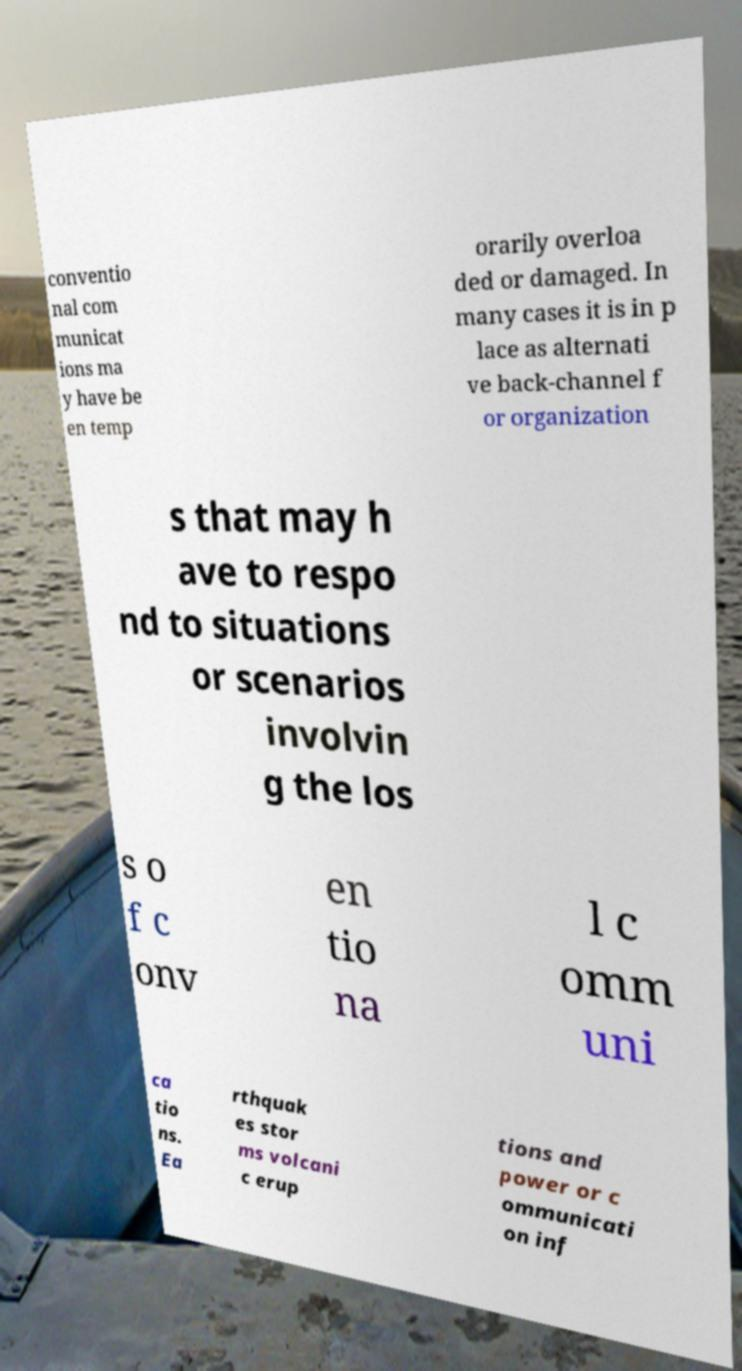Can you read and provide the text displayed in the image?This photo seems to have some interesting text. Can you extract and type it out for me? conventio nal com municat ions ma y have be en temp orarily overloa ded or damaged. In many cases it is in p lace as alternati ve back-channel f or organization s that may h ave to respo nd to situations or scenarios involvin g the los s o f c onv en tio na l c omm uni ca tio ns. Ea rthquak es stor ms volcani c erup tions and power or c ommunicati on inf 